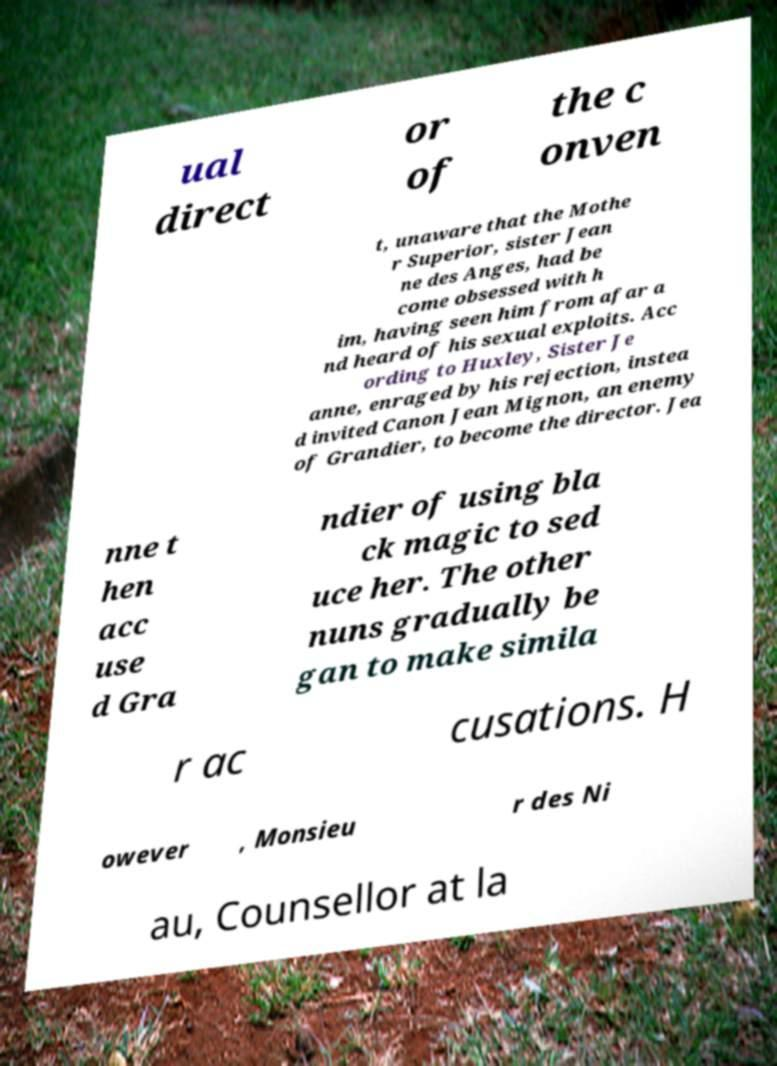Can you read and provide the text displayed in the image?This photo seems to have some interesting text. Can you extract and type it out for me? ual direct or of the c onven t, unaware that the Mothe r Superior, sister Jean ne des Anges, had be come obsessed with h im, having seen him from afar a nd heard of his sexual exploits. Acc ording to Huxley, Sister Je anne, enraged by his rejection, instea d invited Canon Jean Mignon, an enemy of Grandier, to become the director. Jea nne t hen acc use d Gra ndier of using bla ck magic to sed uce her. The other nuns gradually be gan to make simila r ac cusations. H owever , Monsieu r des Ni au, Counsellor at la 